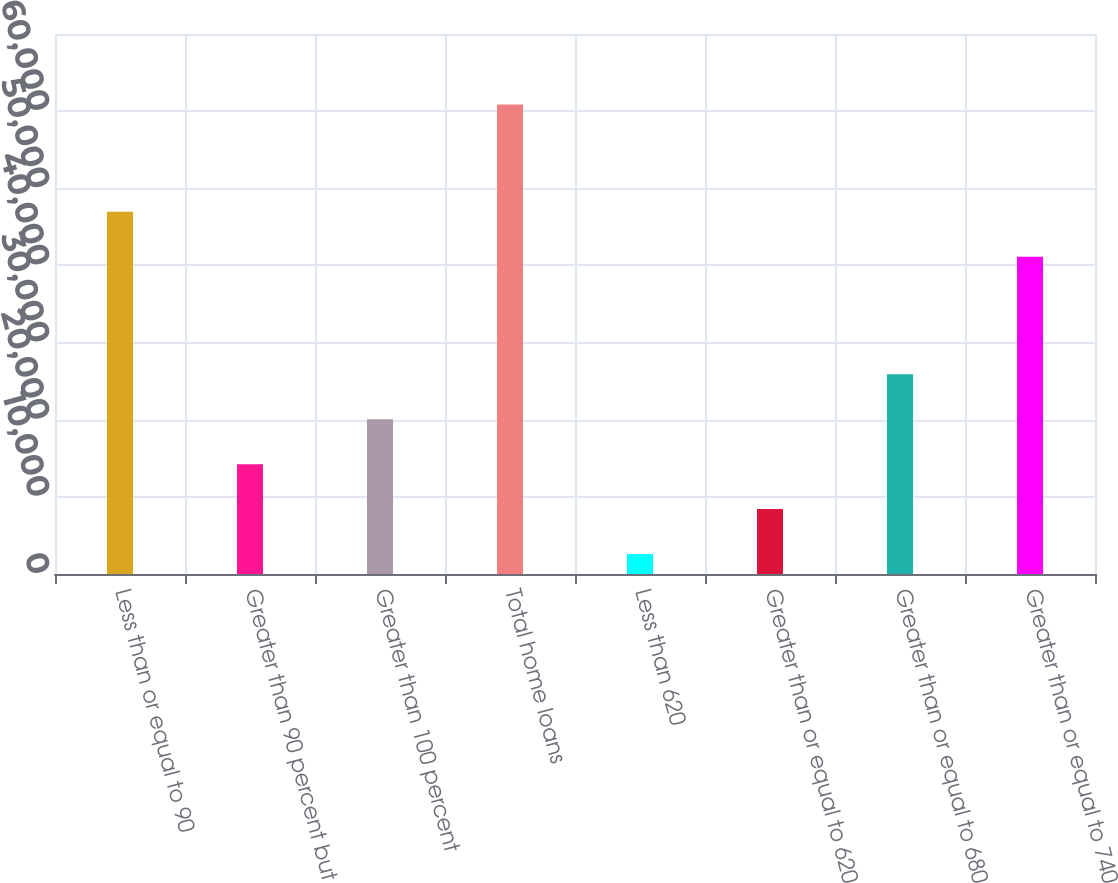Convert chart. <chart><loc_0><loc_0><loc_500><loc_500><bar_chart><fcel>Less than or equal to 90<fcel>Greater than 90 percent but<fcel>Greater than 100 percent<fcel>Total home loans<fcel>Less than 620<fcel>Greater than or equal to 620<fcel>Greater than or equal to 680<fcel>Greater than or equal to 740<nl><fcel>46966.5<fcel>14239<fcel>20065.5<fcel>60851<fcel>2586<fcel>8412.5<fcel>25892<fcel>41140<nl></chart> 